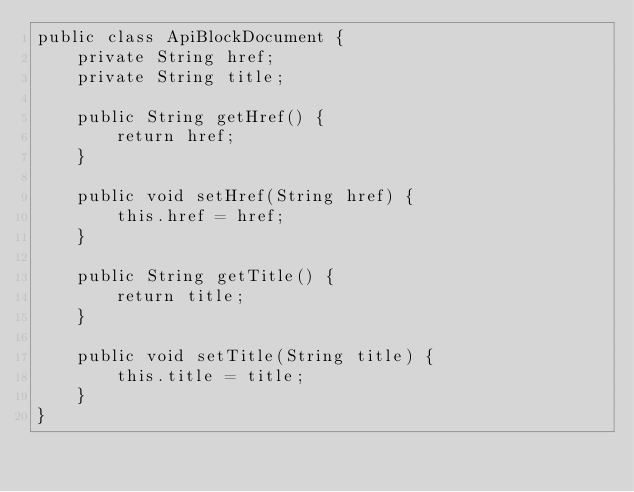<code> <loc_0><loc_0><loc_500><loc_500><_Java_>public class ApiBlockDocument {
    private String href;
    private String title;

    public String getHref() {
        return href;
    }

    public void setHref(String href) {
        this.href = href;
    }

    public String getTitle() {
        return title;
    }

    public void setTitle(String title) {
        this.title = title;
    }
}
</code> 